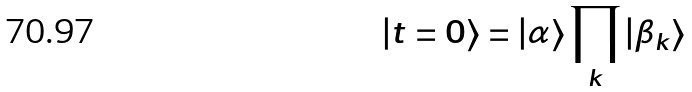<formula> <loc_0><loc_0><loc_500><loc_500>| t = 0 \rangle = | \alpha \rangle \prod _ { k } | \beta _ { k } \rangle</formula> 